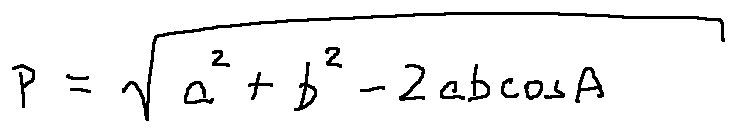Convert formula to latex. <formula><loc_0><loc_0><loc_500><loc_500>p = \sqrt { a ^ { 2 } + b ^ { 2 } - 2 a b \cos A }</formula> 